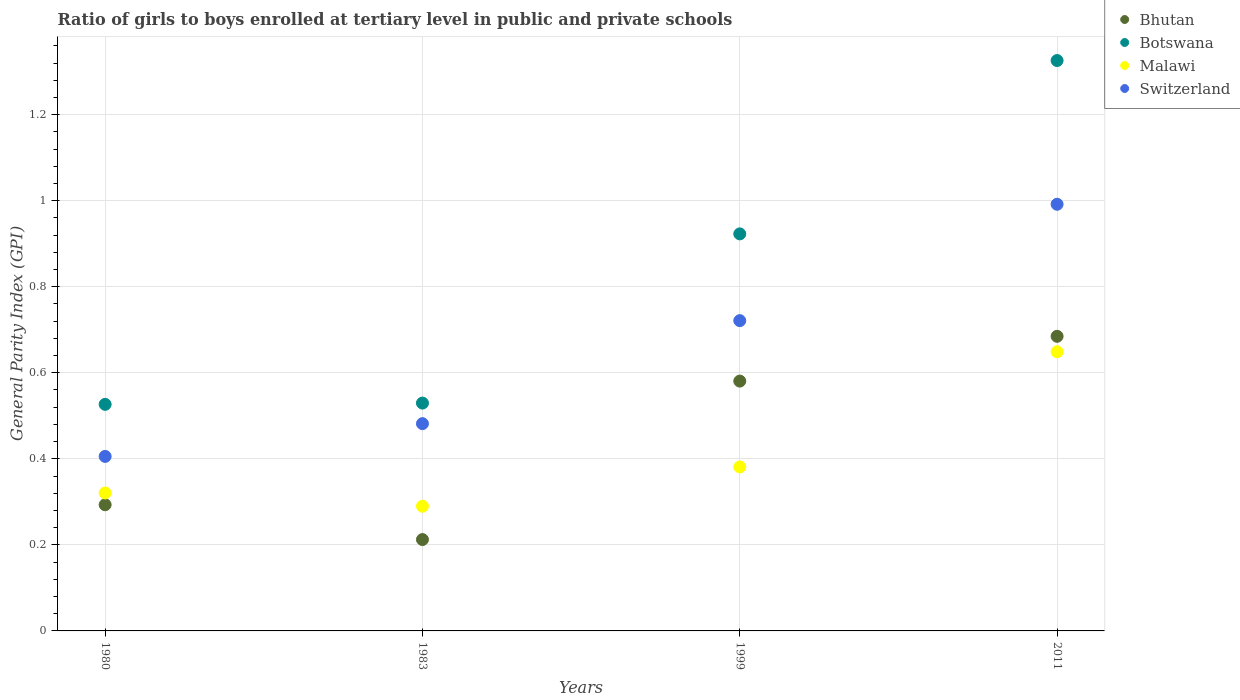How many different coloured dotlines are there?
Provide a short and direct response. 4. What is the general parity index in Bhutan in 1983?
Offer a very short reply. 0.21. Across all years, what is the maximum general parity index in Bhutan?
Provide a short and direct response. 0.68. Across all years, what is the minimum general parity index in Bhutan?
Your answer should be very brief. 0.21. In which year was the general parity index in Botswana maximum?
Keep it short and to the point. 2011. In which year was the general parity index in Switzerland minimum?
Offer a very short reply. 1980. What is the total general parity index in Bhutan in the graph?
Offer a very short reply. 1.77. What is the difference between the general parity index in Switzerland in 1983 and that in 2011?
Make the answer very short. -0.51. What is the difference between the general parity index in Bhutan in 1999 and the general parity index in Malawi in 1980?
Give a very brief answer. 0.26. What is the average general parity index in Botswana per year?
Offer a terse response. 0.83. In the year 2011, what is the difference between the general parity index in Malawi and general parity index in Bhutan?
Offer a very short reply. -0.04. What is the ratio of the general parity index in Switzerland in 1980 to that in 2011?
Give a very brief answer. 0.41. Is the difference between the general parity index in Malawi in 1980 and 1983 greater than the difference between the general parity index in Bhutan in 1980 and 1983?
Give a very brief answer. No. What is the difference between the highest and the second highest general parity index in Switzerland?
Offer a very short reply. 0.27. What is the difference between the highest and the lowest general parity index in Switzerland?
Give a very brief answer. 0.59. Is it the case that in every year, the sum of the general parity index in Bhutan and general parity index in Botswana  is greater than the general parity index in Malawi?
Make the answer very short. Yes. Does the general parity index in Switzerland monotonically increase over the years?
Give a very brief answer. Yes. Does the graph contain grids?
Offer a very short reply. Yes. Where does the legend appear in the graph?
Your answer should be compact. Top right. How are the legend labels stacked?
Offer a terse response. Vertical. What is the title of the graph?
Your answer should be compact. Ratio of girls to boys enrolled at tertiary level in public and private schools. Does "Heavily indebted poor countries" appear as one of the legend labels in the graph?
Give a very brief answer. No. What is the label or title of the Y-axis?
Give a very brief answer. General Parity Index (GPI). What is the General Parity Index (GPI) in Bhutan in 1980?
Offer a very short reply. 0.29. What is the General Parity Index (GPI) of Botswana in 1980?
Provide a succinct answer. 0.53. What is the General Parity Index (GPI) of Malawi in 1980?
Offer a very short reply. 0.32. What is the General Parity Index (GPI) in Switzerland in 1980?
Your response must be concise. 0.41. What is the General Parity Index (GPI) of Bhutan in 1983?
Provide a short and direct response. 0.21. What is the General Parity Index (GPI) in Botswana in 1983?
Provide a short and direct response. 0.53. What is the General Parity Index (GPI) of Malawi in 1983?
Offer a terse response. 0.29. What is the General Parity Index (GPI) of Switzerland in 1983?
Provide a short and direct response. 0.48. What is the General Parity Index (GPI) in Bhutan in 1999?
Ensure brevity in your answer.  0.58. What is the General Parity Index (GPI) in Botswana in 1999?
Your answer should be compact. 0.92. What is the General Parity Index (GPI) in Malawi in 1999?
Provide a short and direct response. 0.38. What is the General Parity Index (GPI) in Switzerland in 1999?
Make the answer very short. 0.72. What is the General Parity Index (GPI) in Bhutan in 2011?
Make the answer very short. 0.68. What is the General Parity Index (GPI) of Botswana in 2011?
Your response must be concise. 1.33. What is the General Parity Index (GPI) of Malawi in 2011?
Offer a terse response. 0.65. What is the General Parity Index (GPI) of Switzerland in 2011?
Provide a short and direct response. 0.99. Across all years, what is the maximum General Parity Index (GPI) in Bhutan?
Your response must be concise. 0.68. Across all years, what is the maximum General Parity Index (GPI) of Botswana?
Provide a short and direct response. 1.33. Across all years, what is the maximum General Parity Index (GPI) of Malawi?
Ensure brevity in your answer.  0.65. Across all years, what is the maximum General Parity Index (GPI) of Switzerland?
Provide a succinct answer. 0.99. Across all years, what is the minimum General Parity Index (GPI) of Bhutan?
Give a very brief answer. 0.21. Across all years, what is the minimum General Parity Index (GPI) in Botswana?
Provide a short and direct response. 0.53. Across all years, what is the minimum General Parity Index (GPI) in Malawi?
Your answer should be compact. 0.29. Across all years, what is the minimum General Parity Index (GPI) in Switzerland?
Your answer should be compact. 0.41. What is the total General Parity Index (GPI) in Bhutan in the graph?
Your response must be concise. 1.77. What is the total General Parity Index (GPI) in Botswana in the graph?
Your response must be concise. 3.3. What is the total General Parity Index (GPI) of Malawi in the graph?
Provide a succinct answer. 1.64. What is the total General Parity Index (GPI) of Switzerland in the graph?
Offer a terse response. 2.6. What is the difference between the General Parity Index (GPI) in Bhutan in 1980 and that in 1983?
Provide a succinct answer. 0.08. What is the difference between the General Parity Index (GPI) of Botswana in 1980 and that in 1983?
Provide a succinct answer. -0. What is the difference between the General Parity Index (GPI) of Malawi in 1980 and that in 1983?
Make the answer very short. 0.03. What is the difference between the General Parity Index (GPI) in Switzerland in 1980 and that in 1983?
Offer a terse response. -0.08. What is the difference between the General Parity Index (GPI) of Bhutan in 1980 and that in 1999?
Provide a short and direct response. -0.29. What is the difference between the General Parity Index (GPI) in Botswana in 1980 and that in 1999?
Ensure brevity in your answer.  -0.4. What is the difference between the General Parity Index (GPI) of Malawi in 1980 and that in 1999?
Provide a short and direct response. -0.06. What is the difference between the General Parity Index (GPI) of Switzerland in 1980 and that in 1999?
Your response must be concise. -0.32. What is the difference between the General Parity Index (GPI) of Bhutan in 1980 and that in 2011?
Offer a very short reply. -0.39. What is the difference between the General Parity Index (GPI) of Botswana in 1980 and that in 2011?
Offer a very short reply. -0.8. What is the difference between the General Parity Index (GPI) in Malawi in 1980 and that in 2011?
Offer a terse response. -0.33. What is the difference between the General Parity Index (GPI) of Switzerland in 1980 and that in 2011?
Offer a very short reply. -0.59. What is the difference between the General Parity Index (GPI) in Bhutan in 1983 and that in 1999?
Give a very brief answer. -0.37. What is the difference between the General Parity Index (GPI) in Botswana in 1983 and that in 1999?
Keep it short and to the point. -0.39. What is the difference between the General Parity Index (GPI) in Malawi in 1983 and that in 1999?
Your response must be concise. -0.09. What is the difference between the General Parity Index (GPI) in Switzerland in 1983 and that in 1999?
Ensure brevity in your answer.  -0.24. What is the difference between the General Parity Index (GPI) in Bhutan in 1983 and that in 2011?
Ensure brevity in your answer.  -0.47. What is the difference between the General Parity Index (GPI) of Botswana in 1983 and that in 2011?
Your answer should be compact. -0.8. What is the difference between the General Parity Index (GPI) in Malawi in 1983 and that in 2011?
Offer a terse response. -0.36. What is the difference between the General Parity Index (GPI) of Switzerland in 1983 and that in 2011?
Provide a succinct answer. -0.51. What is the difference between the General Parity Index (GPI) in Bhutan in 1999 and that in 2011?
Ensure brevity in your answer.  -0.1. What is the difference between the General Parity Index (GPI) of Botswana in 1999 and that in 2011?
Provide a short and direct response. -0.4. What is the difference between the General Parity Index (GPI) in Malawi in 1999 and that in 2011?
Offer a very short reply. -0.27. What is the difference between the General Parity Index (GPI) in Switzerland in 1999 and that in 2011?
Your answer should be very brief. -0.27. What is the difference between the General Parity Index (GPI) of Bhutan in 1980 and the General Parity Index (GPI) of Botswana in 1983?
Your response must be concise. -0.24. What is the difference between the General Parity Index (GPI) of Bhutan in 1980 and the General Parity Index (GPI) of Malawi in 1983?
Keep it short and to the point. 0. What is the difference between the General Parity Index (GPI) in Bhutan in 1980 and the General Parity Index (GPI) in Switzerland in 1983?
Provide a short and direct response. -0.19. What is the difference between the General Parity Index (GPI) in Botswana in 1980 and the General Parity Index (GPI) in Malawi in 1983?
Keep it short and to the point. 0.24. What is the difference between the General Parity Index (GPI) of Botswana in 1980 and the General Parity Index (GPI) of Switzerland in 1983?
Offer a very short reply. 0.04. What is the difference between the General Parity Index (GPI) of Malawi in 1980 and the General Parity Index (GPI) of Switzerland in 1983?
Ensure brevity in your answer.  -0.16. What is the difference between the General Parity Index (GPI) of Bhutan in 1980 and the General Parity Index (GPI) of Botswana in 1999?
Provide a succinct answer. -0.63. What is the difference between the General Parity Index (GPI) of Bhutan in 1980 and the General Parity Index (GPI) of Malawi in 1999?
Offer a very short reply. -0.09. What is the difference between the General Parity Index (GPI) in Bhutan in 1980 and the General Parity Index (GPI) in Switzerland in 1999?
Provide a succinct answer. -0.43. What is the difference between the General Parity Index (GPI) of Botswana in 1980 and the General Parity Index (GPI) of Malawi in 1999?
Your response must be concise. 0.15. What is the difference between the General Parity Index (GPI) of Botswana in 1980 and the General Parity Index (GPI) of Switzerland in 1999?
Provide a succinct answer. -0.19. What is the difference between the General Parity Index (GPI) in Malawi in 1980 and the General Parity Index (GPI) in Switzerland in 1999?
Your response must be concise. -0.4. What is the difference between the General Parity Index (GPI) in Bhutan in 1980 and the General Parity Index (GPI) in Botswana in 2011?
Your answer should be very brief. -1.03. What is the difference between the General Parity Index (GPI) of Bhutan in 1980 and the General Parity Index (GPI) of Malawi in 2011?
Keep it short and to the point. -0.36. What is the difference between the General Parity Index (GPI) in Bhutan in 1980 and the General Parity Index (GPI) in Switzerland in 2011?
Your answer should be compact. -0.7. What is the difference between the General Parity Index (GPI) in Botswana in 1980 and the General Parity Index (GPI) in Malawi in 2011?
Your answer should be very brief. -0.12. What is the difference between the General Parity Index (GPI) of Botswana in 1980 and the General Parity Index (GPI) of Switzerland in 2011?
Your response must be concise. -0.47. What is the difference between the General Parity Index (GPI) of Malawi in 1980 and the General Parity Index (GPI) of Switzerland in 2011?
Provide a succinct answer. -0.67. What is the difference between the General Parity Index (GPI) in Bhutan in 1983 and the General Parity Index (GPI) in Botswana in 1999?
Ensure brevity in your answer.  -0.71. What is the difference between the General Parity Index (GPI) of Bhutan in 1983 and the General Parity Index (GPI) of Malawi in 1999?
Your response must be concise. -0.17. What is the difference between the General Parity Index (GPI) in Bhutan in 1983 and the General Parity Index (GPI) in Switzerland in 1999?
Your answer should be compact. -0.51. What is the difference between the General Parity Index (GPI) in Botswana in 1983 and the General Parity Index (GPI) in Malawi in 1999?
Give a very brief answer. 0.15. What is the difference between the General Parity Index (GPI) in Botswana in 1983 and the General Parity Index (GPI) in Switzerland in 1999?
Make the answer very short. -0.19. What is the difference between the General Parity Index (GPI) of Malawi in 1983 and the General Parity Index (GPI) of Switzerland in 1999?
Ensure brevity in your answer.  -0.43. What is the difference between the General Parity Index (GPI) in Bhutan in 1983 and the General Parity Index (GPI) in Botswana in 2011?
Keep it short and to the point. -1.11. What is the difference between the General Parity Index (GPI) in Bhutan in 1983 and the General Parity Index (GPI) in Malawi in 2011?
Provide a succinct answer. -0.44. What is the difference between the General Parity Index (GPI) in Bhutan in 1983 and the General Parity Index (GPI) in Switzerland in 2011?
Ensure brevity in your answer.  -0.78. What is the difference between the General Parity Index (GPI) in Botswana in 1983 and the General Parity Index (GPI) in Malawi in 2011?
Offer a terse response. -0.12. What is the difference between the General Parity Index (GPI) in Botswana in 1983 and the General Parity Index (GPI) in Switzerland in 2011?
Keep it short and to the point. -0.46. What is the difference between the General Parity Index (GPI) of Malawi in 1983 and the General Parity Index (GPI) of Switzerland in 2011?
Offer a terse response. -0.7. What is the difference between the General Parity Index (GPI) of Bhutan in 1999 and the General Parity Index (GPI) of Botswana in 2011?
Provide a short and direct response. -0.75. What is the difference between the General Parity Index (GPI) in Bhutan in 1999 and the General Parity Index (GPI) in Malawi in 2011?
Your response must be concise. -0.07. What is the difference between the General Parity Index (GPI) in Bhutan in 1999 and the General Parity Index (GPI) in Switzerland in 2011?
Your answer should be compact. -0.41. What is the difference between the General Parity Index (GPI) in Botswana in 1999 and the General Parity Index (GPI) in Malawi in 2011?
Offer a very short reply. 0.27. What is the difference between the General Parity Index (GPI) of Botswana in 1999 and the General Parity Index (GPI) of Switzerland in 2011?
Offer a very short reply. -0.07. What is the difference between the General Parity Index (GPI) in Malawi in 1999 and the General Parity Index (GPI) in Switzerland in 2011?
Offer a terse response. -0.61. What is the average General Parity Index (GPI) of Bhutan per year?
Provide a short and direct response. 0.44. What is the average General Parity Index (GPI) of Botswana per year?
Offer a very short reply. 0.83. What is the average General Parity Index (GPI) of Malawi per year?
Keep it short and to the point. 0.41. What is the average General Parity Index (GPI) in Switzerland per year?
Give a very brief answer. 0.65. In the year 1980, what is the difference between the General Parity Index (GPI) of Bhutan and General Parity Index (GPI) of Botswana?
Offer a very short reply. -0.23. In the year 1980, what is the difference between the General Parity Index (GPI) of Bhutan and General Parity Index (GPI) of Malawi?
Provide a succinct answer. -0.03. In the year 1980, what is the difference between the General Parity Index (GPI) in Bhutan and General Parity Index (GPI) in Switzerland?
Your answer should be compact. -0.11. In the year 1980, what is the difference between the General Parity Index (GPI) of Botswana and General Parity Index (GPI) of Malawi?
Your answer should be compact. 0.21. In the year 1980, what is the difference between the General Parity Index (GPI) of Botswana and General Parity Index (GPI) of Switzerland?
Offer a very short reply. 0.12. In the year 1980, what is the difference between the General Parity Index (GPI) of Malawi and General Parity Index (GPI) of Switzerland?
Your response must be concise. -0.09. In the year 1983, what is the difference between the General Parity Index (GPI) in Bhutan and General Parity Index (GPI) in Botswana?
Keep it short and to the point. -0.32. In the year 1983, what is the difference between the General Parity Index (GPI) of Bhutan and General Parity Index (GPI) of Malawi?
Keep it short and to the point. -0.08. In the year 1983, what is the difference between the General Parity Index (GPI) in Bhutan and General Parity Index (GPI) in Switzerland?
Make the answer very short. -0.27. In the year 1983, what is the difference between the General Parity Index (GPI) in Botswana and General Parity Index (GPI) in Malawi?
Make the answer very short. 0.24. In the year 1983, what is the difference between the General Parity Index (GPI) in Botswana and General Parity Index (GPI) in Switzerland?
Ensure brevity in your answer.  0.05. In the year 1983, what is the difference between the General Parity Index (GPI) of Malawi and General Parity Index (GPI) of Switzerland?
Your answer should be very brief. -0.19. In the year 1999, what is the difference between the General Parity Index (GPI) of Bhutan and General Parity Index (GPI) of Botswana?
Provide a short and direct response. -0.34. In the year 1999, what is the difference between the General Parity Index (GPI) of Bhutan and General Parity Index (GPI) of Malawi?
Provide a short and direct response. 0.2. In the year 1999, what is the difference between the General Parity Index (GPI) of Bhutan and General Parity Index (GPI) of Switzerland?
Offer a very short reply. -0.14. In the year 1999, what is the difference between the General Parity Index (GPI) in Botswana and General Parity Index (GPI) in Malawi?
Your answer should be very brief. 0.54. In the year 1999, what is the difference between the General Parity Index (GPI) of Botswana and General Parity Index (GPI) of Switzerland?
Your response must be concise. 0.2. In the year 1999, what is the difference between the General Parity Index (GPI) in Malawi and General Parity Index (GPI) in Switzerland?
Your answer should be very brief. -0.34. In the year 2011, what is the difference between the General Parity Index (GPI) in Bhutan and General Parity Index (GPI) in Botswana?
Ensure brevity in your answer.  -0.64. In the year 2011, what is the difference between the General Parity Index (GPI) in Bhutan and General Parity Index (GPI) in Malawi?
Offer a terse response. 0.04. In the year 2011, what is the difference between the General Parity Index (GPI) of Bhutan and General Parity Index (GPI) of Switzerland?
Your response must be concise. -0.31. In the year 2011, what is the difference between the General Parity Index (GPI) of Botswana and General Parity Index (GPI) of Malawi?
Offer a very short reply. 0.68. In the year 2011, what is the difference between the General Parity Index (GPI) of Botswana and General Parity Index (GPI) of Switzerland?
Provide a succinct answer. 0.33. In the year 2011, what is the difference between the General Parity Index (GPI) in Malawi and General Parity Index (GPI) in Switzerland?
Your answer should be very brief. -0.34. What is the ratio of the General Parity Index (GPI) of Bhutan in 1980 to that in 1983?
Make the answer very short. 1.38. What is the ratio of the General Parity Index (GPI) in Malawi in 1980 to that in 1983?
Ensure brevity in your answer.  1.11. What is the ratio of the General Parity Index (GPI) in Switzerland in 1980 to that in 1983?
Your response must be concise. 0.84. What is the ratio of the General Parity Index (GPI) of Bhutan in 1980 to that in 1999?
Offer a very short reply. 0.51. What is the ratio of the General Parity Index (GPI) in Botswana in 1980 to that in 1999?
Offer a very short reply. 0.57. What is the ratio of the General Parity Index (GPI) of Malawi in 1980 to that in 1999?
Make the answer very short. 0.84. What is the ratio of the General Parity Index (GPI) of Switzerland in 1980 to that in 1999?
Provide a succinct answer. 0.56. What is the ratio of the General Parity Index (GPI) in Bhutan in 1980 to that in 2011?
Offer a terse response. 0.43. What is the ratio of the General Parity Index (GPI) of Botswana in 1980 to that in 2011?
Make the answer very short. 0.4. What is the ratio of the General Parity Index (GPI) in Malawi in 1980 to that in 2011?
Offer a very short reply. 0.49. What is the ratio of the General Parity Index (GPI) in Switzerland in 1980 to that in 2011?
Make the answer very short. 0.41. What is the ratio of the General Parity Index (GPI) of Bhutan in 1983 to that in 1999?
Provide a short and direct response. 0.37. What is the ratio of the General Parity Index (GPI) of Botswana in 1983 to that in 1999?
Offer a very short reply. 0.57. What is the ratio of the General Parity Index (GPI) of Malawi in 1983 to that in 1999?
Your answer should be compact. 0.76. What is the ratio of the General Parity Index (GPI) in Switzerland in 1983 to that in 1999?
Ensure brevity in your answer.  0.67. What is the ratio of the General Parity Index (GPI) in Bhutan in 1983 to that in 2011?
Your answer should be very brief. 0.31. What is the ratio of the General Parity Index (GPI) of Botswana in 1983 to that in 2011?
Ensure brevity in your answer.  0.4. What is the ratio of the General Parity Index (GPI) in Malawi in 1983 to that in 2011?
Provide a succinct answer. 0.45. What is the ratio of the General Parity Index (GPI) in Switzerland in 1983 to that in 2011?
Give a very brief answer. 0.49. What is the ratio of the General Parity Index (GPI) in Bhutan in 1999 to that in 2011?
Your answer should be compact. 0.85. What is the ratio of the General Parity Index (GPI) of Botswana in 1999 to that in 2011?
Offer a terse response. 0.7. What is the ratio of the General Parity Index (GPI) of Malawi in 1999 to that in 2011?
Your answer should be very brief. 0.59. What is the ratio of the General Parity Index (GPI) of Switzerland in 1999 to that in 2011?
Offer a very short reply. 0.73. What is the difference between the highest and the second highest General Parity Index (GPI) of Bhutan?
Your response must be concise. 0.1. What is the difference between the highest and the second highest General Parity Index (GPI) of Botswana?
Offer a terse response. 0.4. What is the difference between the highest and the second highest General Parity Index (GPI) in Malawi?
Offer a very short reply. 0.27. What is the difference between the highest and the second highest General Parity Index (GPI) of Switzerland?
Your response must be concise. 0.27. What is the difference between the highest and the lowest General Parity Index (GPI) in Bhutan?
Make the answer very short. 0.47. What is the difference between the highest and the lowest General Parity Index (GPI) in Botswana?
Your answer should be compact. 0.8. What is the difference between the highest and the lowest General Parity Index (GPI) in Malawi?
Provide a succinct answer. 0.36. What is the difference between the highest and the lowest General Parity Index (GPI) of Switzerland?
Provide a succinct answer. 0.59. 